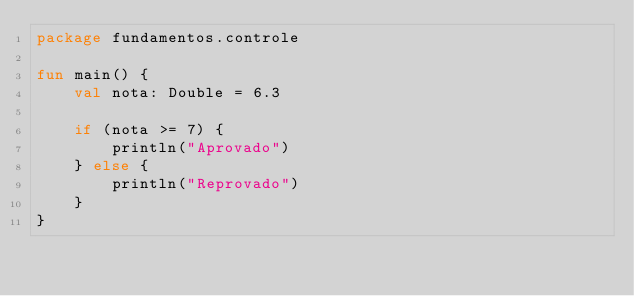Convert code to text. <code><loc_0><loc_0><loc_500><loc_500><_Kotlin_>package fundamentos.controle

fun main() {
    val nota: Double = 6.3

    if (nota >= 7) {
        println("Aprovado")
    } else {
        println("Reprovado")
    }
}</code> 